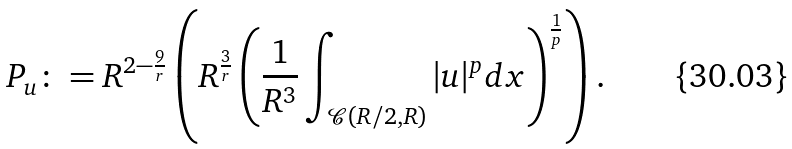Convert formula to latex. <formula><loc_0><loc_0><loc_500><loc_500>P _ { u } \colon = R ^ { 2 - \frac { 9 } { r } } \left ( R ^ { \frac { 3 } { r } } \left ( \frac { 1 } { R ^ { 3 } } \int _ { \mathcal { C } ( R / 2 , R ) } | u | ^ { p } d x \right ) ^ { \frac { 1 } { p } } \right ) .</formula> 